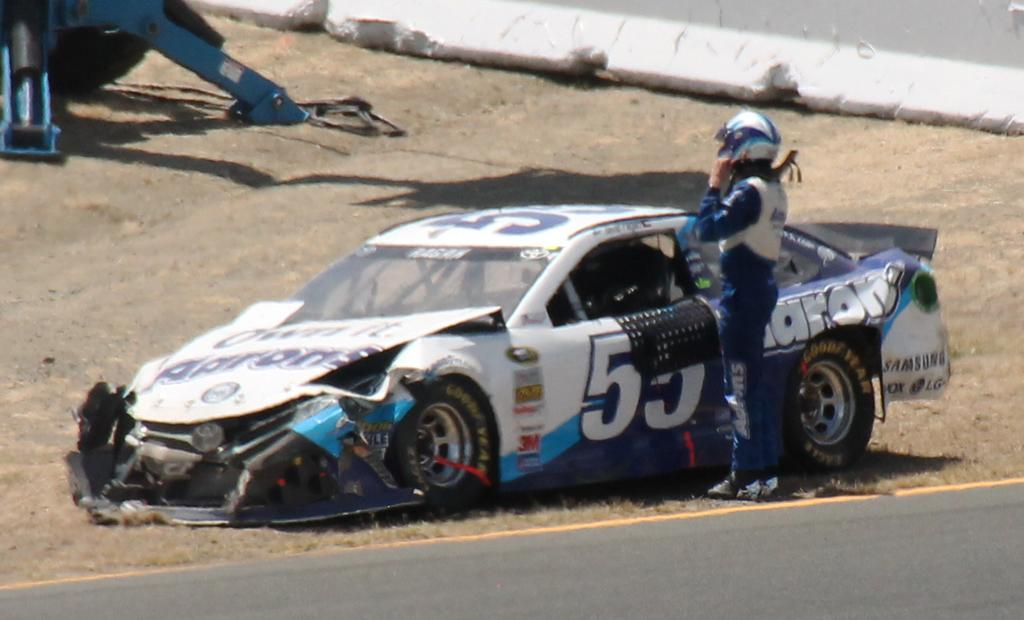What is the main feature in the center of the image? There is a road in the center of the image. What is on the road? There is a car on the road. Who is near the car? A person is standing near the car. What is the person wearing? The person is wearing a helmet. What can be seen in the background of the image? There is a wall, a blue object, and grass in the background of the image. What type of grain is being harvested in the background of the image? There is no grain visible in the image; the background features a wall, a blue object, and grass. 